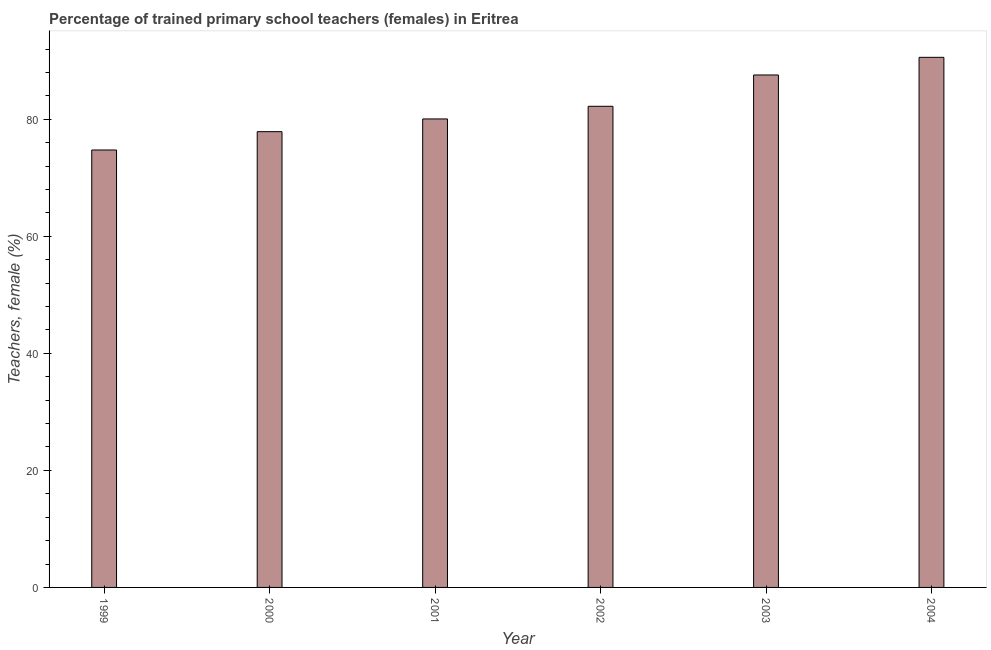What is the title of the graph?
Give a very brief answer. Percentage of trained primary school teachers (females) in Eritrea. What is the label or title of the Y-axis?
Provide a succinct answer. Teachers, female (%). What is the percentage of trained female teachers in 2001?
Ensure brevity in your answer.  80.07. Across all years, what is the maximum percentage of trained female teachers?
Give a very brief answer. 90.59. Across all years, what is the minimum percentage of trained female teachers?
Provide a short and direct response. 74.76. What is the sum of the percentage of trained female teachers?
Your response must be concise. 493.12. What is the difference between the percentage of trained female teachers in 2001 and 2002?
Give a very brief answer. -2.16. What is the average percentage of trained female teachers per year?
Give a very brief answer. 82.19. What is the median percentage of trained female teachers?
Ensure brevity in your answer.  81.15. What is the ratio of the percentage of trained female teachers in 1999 to that in 2001?
Provide a short and direct response. 0.93. Is the percentage of trained female teachers in 2000 less than that in 2002?
Make the answer very short. Yes. What is the difference between the highest and the second highest percentage of trained female teachers?
Make the answer very short. 3.02. What is the difference between the highest and the lowest percentage of trained female teachers?
Keep it short and to the point. 15.84. In how many years, is the percentage of trained female teachers greater than the average percentage of trained female teachers taken over all years?
Your answer should be compact. 3. Are all the bars in the graph horizontal?
Your answer should be very brief. No. How many years are there in the graph?
Your response must be concise. 6. Are the values on the major ticks of Y-axis written in scientific E-notation?
Your answer should be compact. No. What is the Teachers, female (%) in 1999?
Make the answer very short. 74.76. What is the Teachers, female (%) of 2000?
Provide a short and direct response. 77.89. What is the Teachers, female (%) of 2001?
Offer a terse response. 80.07. What is the Teachers, female (%) of 2002?
Your answer should be compact. 82.23. What is the Teachers, female (%) of 2003?
Your answer should be compact. 87.58. What is the Teachers, female (%) of 2004?
Provide a succinct answer. 90.59. What is the difference between the Teachers, female (%) in 1999 and 2000?
Ensure brevity in your answer.  -3.13. What is the difference between the Teachers, female (%) in 1999 and 2001?
Your response must be concise. -5.31. What is the difference between the Teachers, female (%) in 1999 and 2002?
Your response must be concise. -7.47. What is the difference between the Teachers, female (%) in 1999 and 2003?
Offer a very short reply. -12.82. What is the difference between the Teachers, female (%) in 1999 and 2004?
Provide a succinct answer. -15.84. What is the difference between the Teachers, female (%) in 2000 and 2001?
Offer a very short reply. -2.17. What is the difference between the Teachers, female (%) in 2000 and 2002?
Keep it short and to the point. -4.34. What is the difference between the Teachers, female (%) in 2000 and 2003?
Keep it short and to the point. -9.69. What is the difference between the Teachers, female (%) in 2000 and 2004?
Provide a short and direct response. -12.7. What is the difference between the Teachers, female (%) in 2001 and 2002?
Ensure brevity in your answer.  -2.16. What is the difference between the Teachers, female (%) in 2001 and 2003?
Give a very brief answer. -7.51. What is the difference between the Teachers, female (%) in 2001 and 2004?
Your answer should be compact. -10.53. What is the difference between the Teachers, female (%) in 2002 and 2003?
Keep it short and to the point. -5.35. What is the difference between the Teachers, female (%) in 2002 and 2004?
Provide a succinct answer. -8.37. What is the difference between the Teachers, female (%) in 2003 and 2004?
Your answer should be compact. -3.02. What is the ratio of the Teachers, female (%) in 1999 to that in 2000?
Your answer should be very brief. 0.96. What is the ratio of the Teachers, female (%) in 1999 to that in 2001?
Provide a succinct answer. 0.93. What is the ratio of the Teachers, female (%) in 1999 to that in 2002?
Provide a short and direct response. 0.91. What is the ratio of the Teachers, female (%) in 1999 to that in 2003?
Ensure brevity in your answer.  0.85. What is the ratio of the Teachers, female (%) in 1999 to that in 2004?
Make the answer very short. 0.82. What is the ratio of the Teachers, female (%) in 2000 to that in 2002?
Offer a very short reply. 0.95. What is the ratio of the Teachers, female (%) in 2000 to that in 2003?
Offer a very short reply. 0.89. What is the ratio of the Teachers, female (%) in 2000 to that in 2004?
Provide a succinct answer. 0.86. What is the ratio of the Teachers, female (%) in 2001 to that in 2002?
Your response must be concise. 0.97. What is the ratio of the Teachers, female (%) in 2001 to that in 2003?
Ensure brevity in your answer.  0.91. What is the ratio of the Teachers, female (%) in 2001 to that in 2004?
Offer a terse response. 0.88. What is the ratio of the Teachers, female (%) in 2002 to that in 2003?
Ensure brevity in your answer.  0.94. What is the ratio of the Teachers, female (%) in 2002 to that in 2004?
Your answer should be very brief. 0.91. 